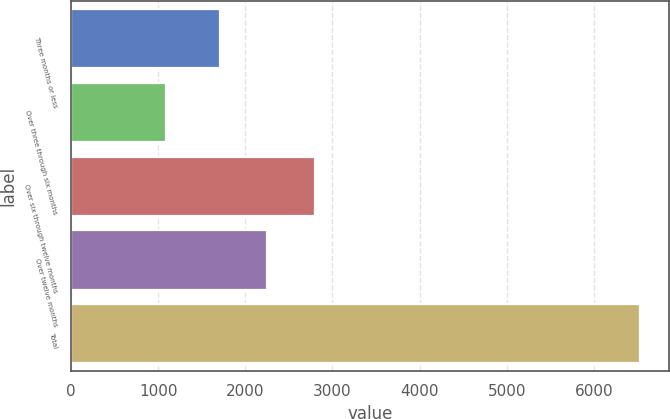Convert chart. <chart><loc_0><loc_0><loc_500><loc_500><bar_chart><fcel>Three months or less<fcel>Over three through six months<fcel>Over six through twelve months<fcel>Over twelve months<fcel>Total<nl><fcel>1706<fcel>1089<fcel>2795.4<fcel>2250.7<fcel>6536<nl></chart> 